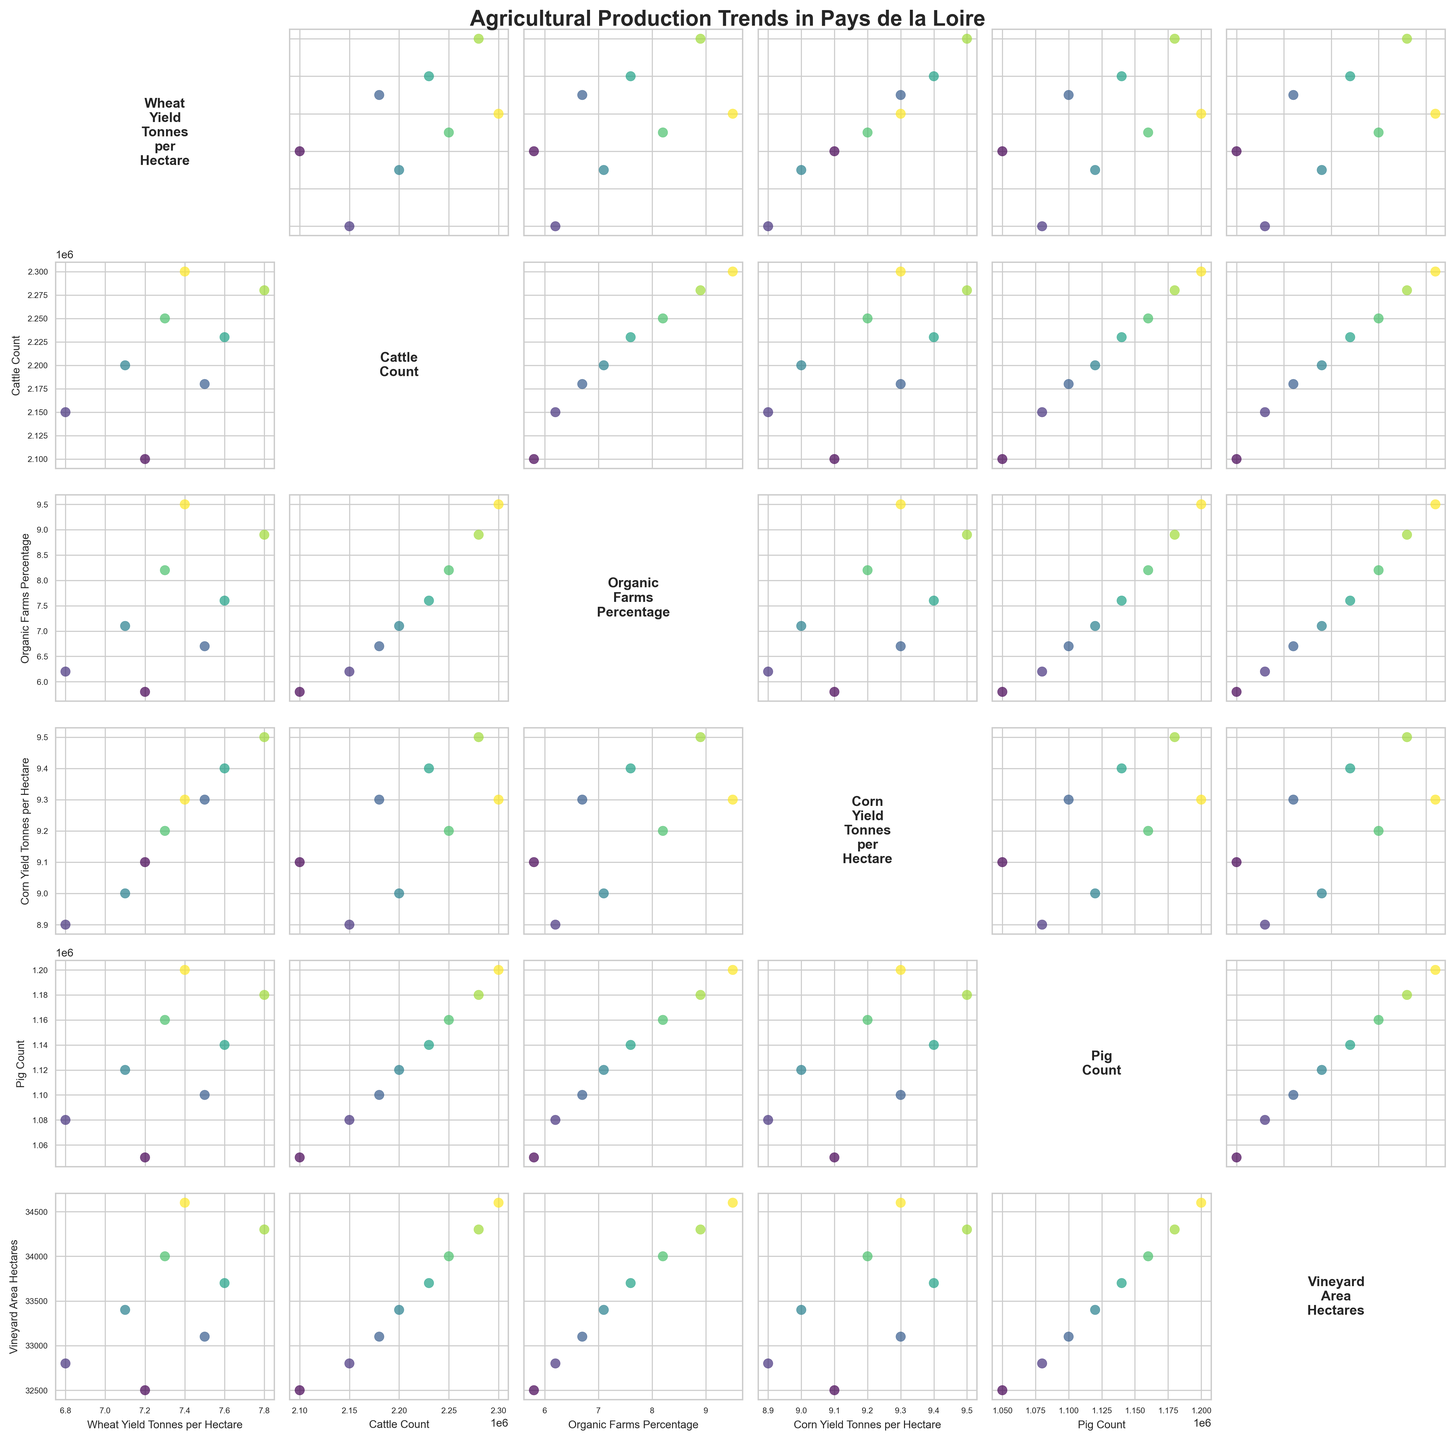How many variables are displayed in the scatterplot matrix? The scatterplot matrix includes six variables as shown by the matrix dimensions and variable list: 'Wheat Yield Tonnes per Hectare', 'Cattle Count', 'Organic Farms Percentage', 'Corn Yield Tonnes per Hectare', 'Pig Count', and 'Vineyard Area Hectares'.
Answer: Six Which variable has the title 'Agricultural Production Trends in Pays de la Loire'? The title of the scatterplot matrix is 'Agricultural Production Trends in Pays de la Loire', as seen at the top of the figure.
Answer: Overall title What is the relationship between 'Organic Farms Percentage' and 'Cattle Count'? By examining the scatterplot located at the intersection of 'Organic Farms Percentage' (x-axis) and 'Cattle Count' (y-axis), look for any patterns or correlations. The data points show a positive trend, indicating that as 'Organic Farms Percentage' increases, 'Cattle Count' also tends to increase.
Answer: Positive correlation What appears to be the trend between 'Pig Count' and 'Corn Yield Tonnes per Hectare'? By observing the scatterplot at the intersection of 'Pig Count' (x-axis) and 'Corn Yield Tonnes per Hectare' (y-axis), there is a slightly positive or neutral trend, showing that 'Corn Yield' does not strongly correlate with 'Pig Count'.
Answer: Slightly positive or neutral Which two variables show the strongest positive correlation? Comparing the scatterplots, 'Organic Farms Percentage' and 'Cattle Count' appear to show the strongest positive correlation as the data points are closely clustered along a rising trend.
Answer: 'Organic Farms Percentage' and 'Cattle Count' What color is used to represent data points from the year 2022? Data points for different years are color-coded using a gradient color map (viridis), where the latest year (2022) is represented by the darkest (or last) color in the color map. By checking the color map legend or inferred trend, the year 2022 is represented by dark blue/purple.
Answer: Dark blue/purple Is there an apparent trend between 'Wheat Yield Tonnes per Hectare' and 'Vineyard Area Hectares'? By looking at the scatterplot where 'Wheat Yield Tonnes per Hectare' is on one axis and 'Vineyard Area Hectares' on the other, no clear trend is observed, indicating no strong correlation between these variables.
Answer: No apparent trend How does the 'Vineyard Area Hectares' change over the years? In the scatterplot where 'Year' (color-coded) is plotted against 'Vineyard Area Hectares', observe the color trend across the years. The 'Vineyard Area Hectares' shows a gradual increase from 2015 to 2022.
Answer: Gradual increase Are there any years where 'Corn Yield Tonnes per Hectare' significantly drops? By viewing the color-coded data points for 'Year' on the scatterplot of 'Corn Yield Tonnes per Hectare', notice that the year 2016 shows a slight drop compared to surrounding years. This drop is not very significant but is the lowest among the values.
Answer: 2016 Which two variables appear to have a consistent linear relationship over time? 'Wheat Yield Tonnes per Hectare' and 'Corn Yield Tonnes per Hectare' form a scatterplot which consistently spreads in a linear fashion, indicating that their relationship is somewhat linear and consistent across time periods.
Answer: 'Wheat Yield' and 'Corn Yield' 